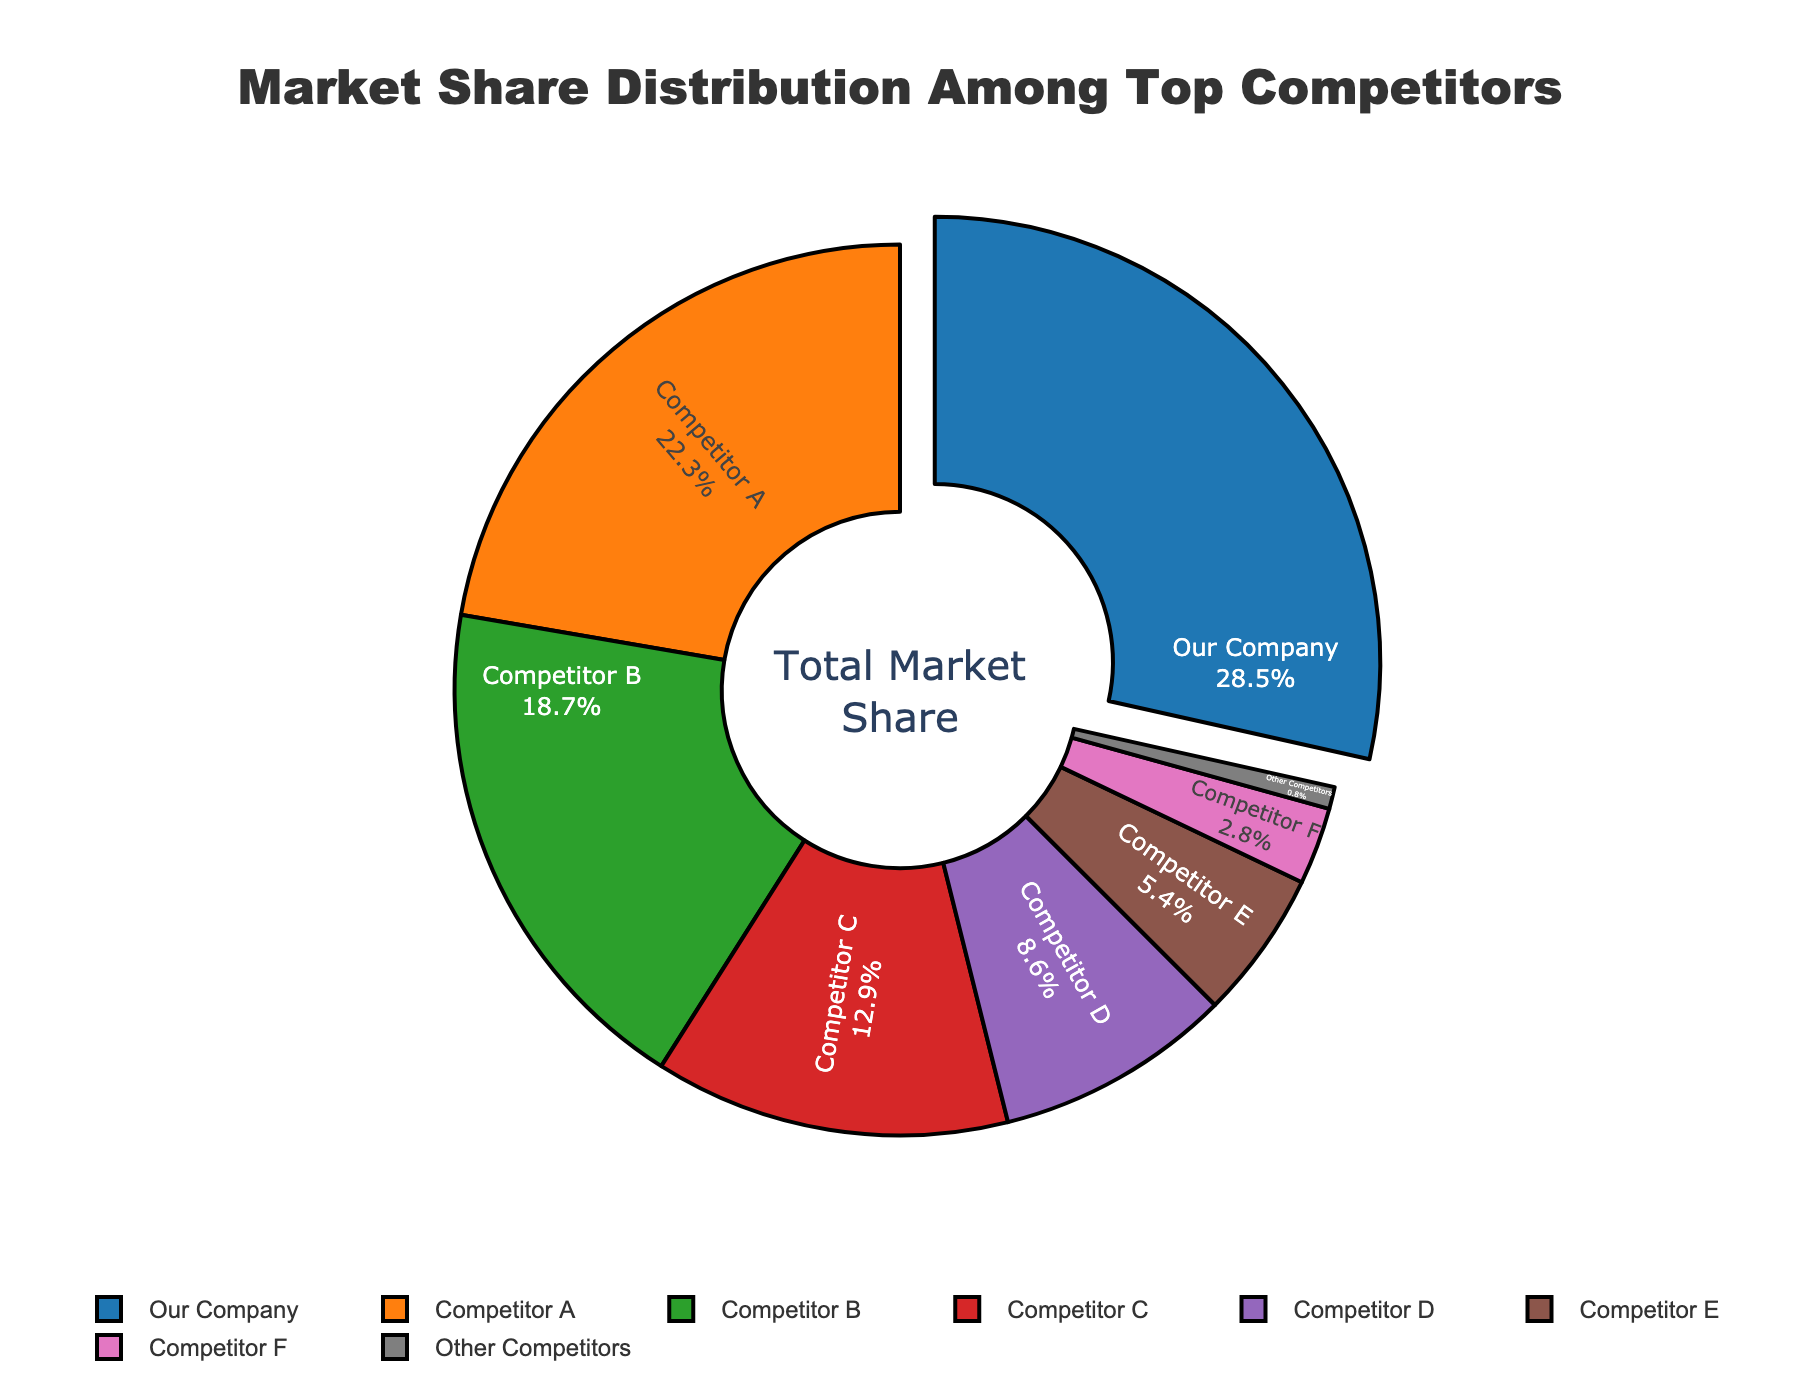What is the market share of Competitor B? To find the market share of Competitor B, look at the section labeled "Competitor B" in the chart. The percentage is displayed inside the section.
Answer: 18.7% Which company has the largest market share, and what is it? To determine the company with the largest market share, look for the section with the largest area or slice in the pie chart. The percentage inside this section will indicate the market share.
Answer: Our Company, 28.5% How do the market shares of Competitor A and Competitor C compare? Locate the sections for Competitor A and Competitor C. Compare the percentages shown inside their respective sections.
Answer: Competitor A has a larger market share (22.3%) than Competitor C (12.9%) What's the sum of market shares for Competitor D and Competitor E? Look for sections labeled "Competitor D" and "Competitor E." Add their percentages together: 8.6% + 5.4% = 14.0%.
Answer: 14.0% Is Our Company’s market share more than the combined market share of Competitor B and Competitor C? Locate the market share for Our Company (28.5%). Calculate the combined market share of Competitor B (18.7%) and Competitor C (12.9%): 18.7% + 12.9% = 31.6%. Compare the two values: 28.5% < 31.6%.
Answer: No How many companies have a market share of less than 10%? Count the number of sections where the market share percentage is less than 10%. Specifically, Competitor D (8.6%), Competitor E (5.4%), Competitor F (2.8%), and Other Competitors (0.8%).
Answer: 4 What is the total market share for companies excluding Our Company? Subtract Our Company’s market share from the total (100%): 100% - 28.5% = 71.5%.
Answer: 71.5% Which competitor has the smallest market share, and what is the percentage? Identify the smallest section in the pie chart labeled "Other Competitors." Check the percentage inside this section.
Answer: Other Competitors, 0.8% Compare the combined market share of Competitors E and F with that of Competitor B. Which is greater? Locate the sections for Competitors E (5.4%) and F (2.8%). Calculate their combined total: 5.4% + 2.8% = 8.2%. Compare this with Competitor B's market share (18.7%): 8.2% < 18.7%.
Answer: Competitor B What percentage of the market do Competitor A, Competitor B, and Competitor C collectively hold? Add the market shares of Competitor A (22.3%), Competitor B (18.7%), and Competitor C (12.9%): 22.3% + 18.7% + 12.9% = 53.9%.
Answer: 53.9% 